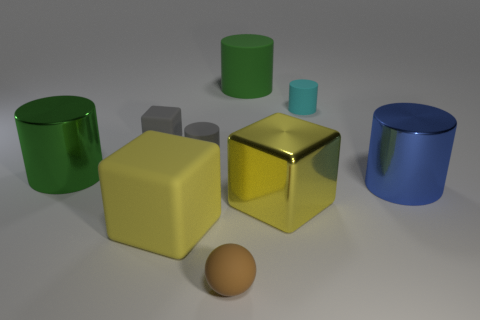How many green cylinders must be subtracted to get 1 green cylinders? 1 Subtract all small gray matte cylinders. How many cylinders are left? 4 Add 1 big green rubber cylinders. How many objects exist? 10 Subtract all gray blocks. How many blocks are left? 2 Subtract 0 purple cubes. How many objects are left? 9 Subtract all cylinders. How many objects are left? 4 Subtract 3 cylinders. How many cylinders are left? 2 Subtract all blue cylinders. Subtract all brown balls. How many cylinders are left? 4 Subtract all red cylinders. How many yellow blocks are left? 2 Subtract all big red things. Subtract all big blue shiny things. How many objects are left? 8 